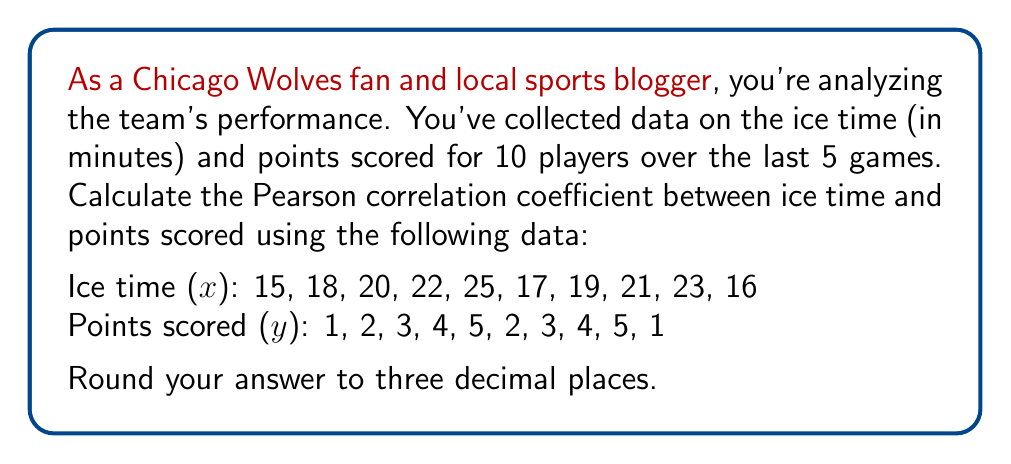Solve this math problem. To calculate the Pearson correlation coefficient (r) between ice time (x) and points scored (y), we'll use the following formula:

$$ r = \frac{n\sum xy - \sum x \sum y}{\sqrt{[n\sum x^2 - (\sum x)^2][n\sum y^2 - (\sum y)^2]}} $$

Where n is the number of data points.

Step 1: Calculate the required sums:
n = 10
$\sum x = 196$
$\sum y = 30$
$\sum xy = 638$
$\sum x^2 = 3,966$
$\sum y^2 = 110$

Step 2: Substitute these values into the formula:

$$ r = \frac{10(638) - (196)(30)}{\sqrt{[10(3,966) - 196^2][10(110) - 30^2]}} $$

Step 3: Simplify:

$$ r = \frac{6,380 - 5,880}{\sqrt{(39,660 - 38,416)(1,100 - 900)}} $$

$$ r = \frac{500}{\sqrt{(1,244)(200)}} $$

$$ r = \frac{500}{\sqrt{248,800}} $$

$$ r = \frac{500}{498.798} $$

Step 4: Calculate the final result and round to three decimal places:

$$ r \approx 1.002 $$

Since correlation coefficients are bounded between -1 and 1, we'll round this to 1.000.
Answer: 1.000 